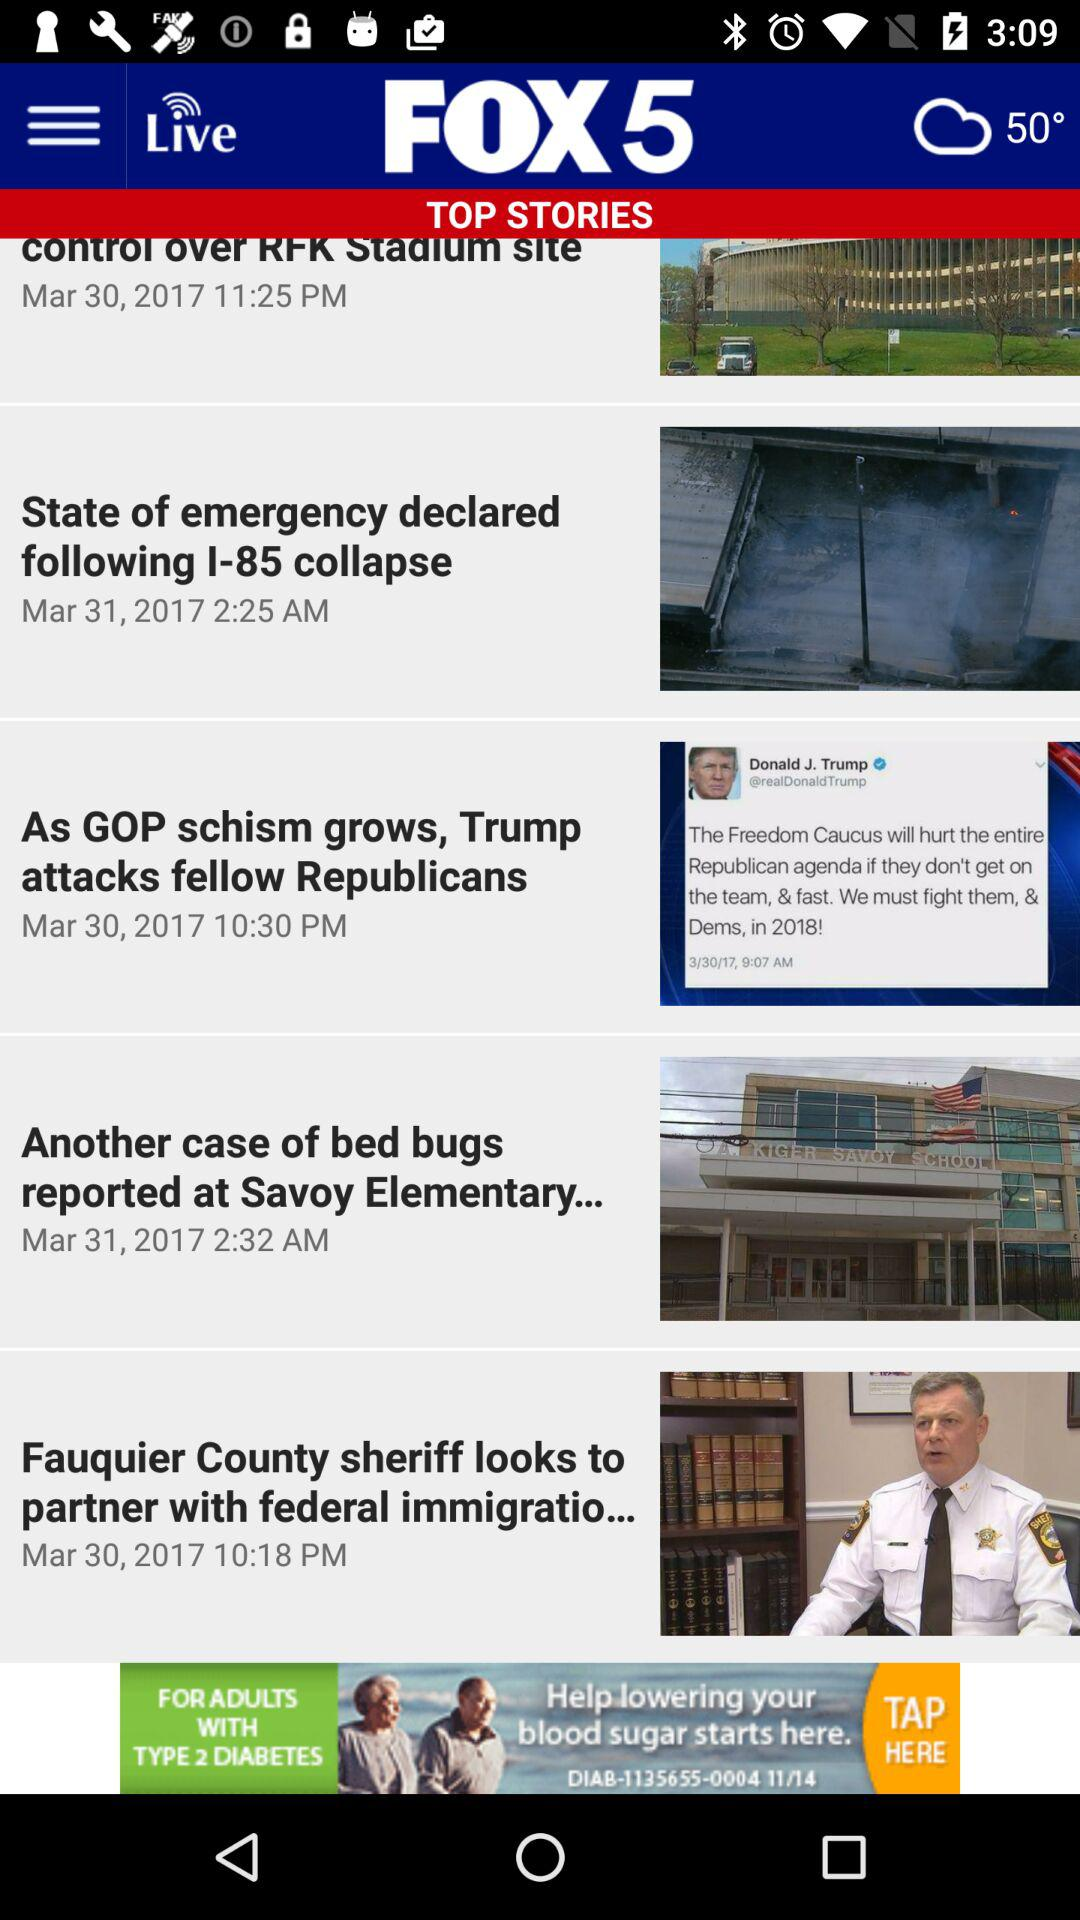How many news items are there?
Answer the question using a single word or phrase. 5 